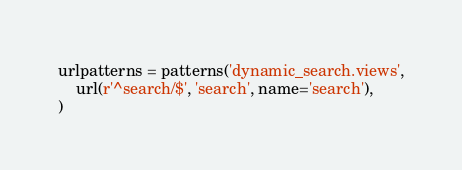<code> <loc_0><loc_0><loc_500><loc_500><_Python_>
urlpatterns = patterns('dynamic_search.views',
    url(r'^search/$', 'search', name='search'),
)


</code> 